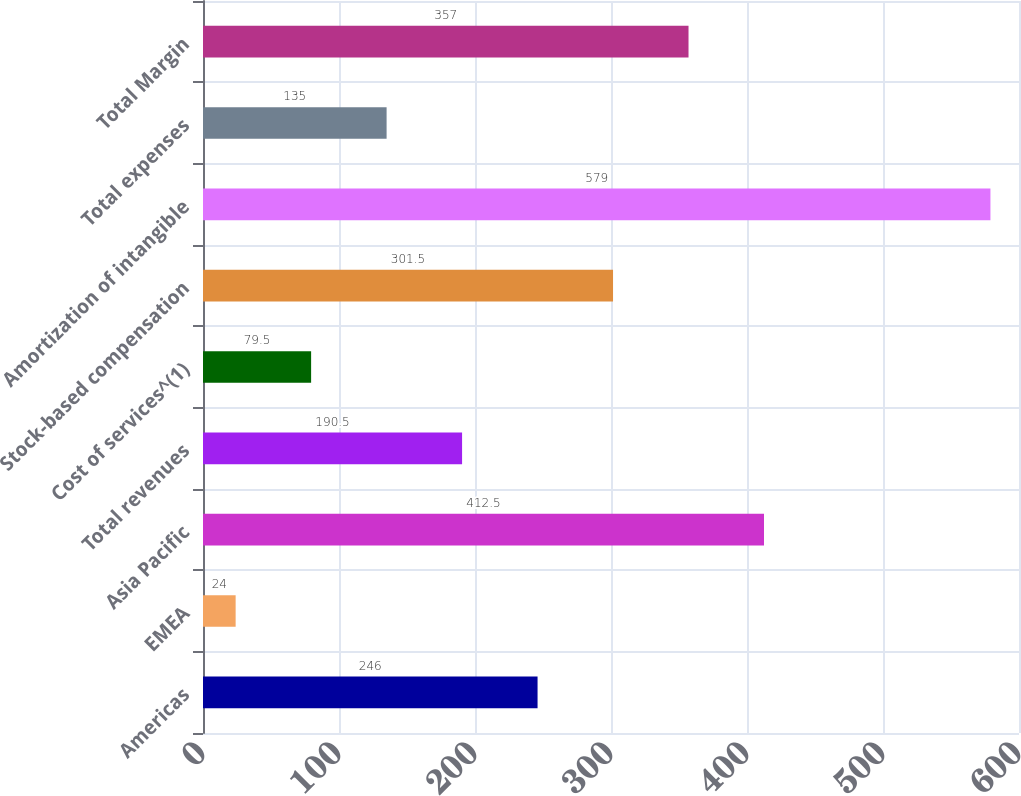Convert chart to OTSL. <chart><loc_0><loc_0><loc_500><loc_500><bar_chart><fcel>Americas<fcel>EMEA<fcel>Asia Pacific<fcel>Total revenues<fcel>Cost of services^(1)<fcel>Stock-based compensation<fcel>Amortization of intangible<fcel>Total expenses<fcel>Total Margin<nl><fcel>246<fcel>24<fcel>412.5<fcel>190.5<fcel>79.5<fcel>301.5<fcel>579<fcel>135<fcel>357<nl></chart> 